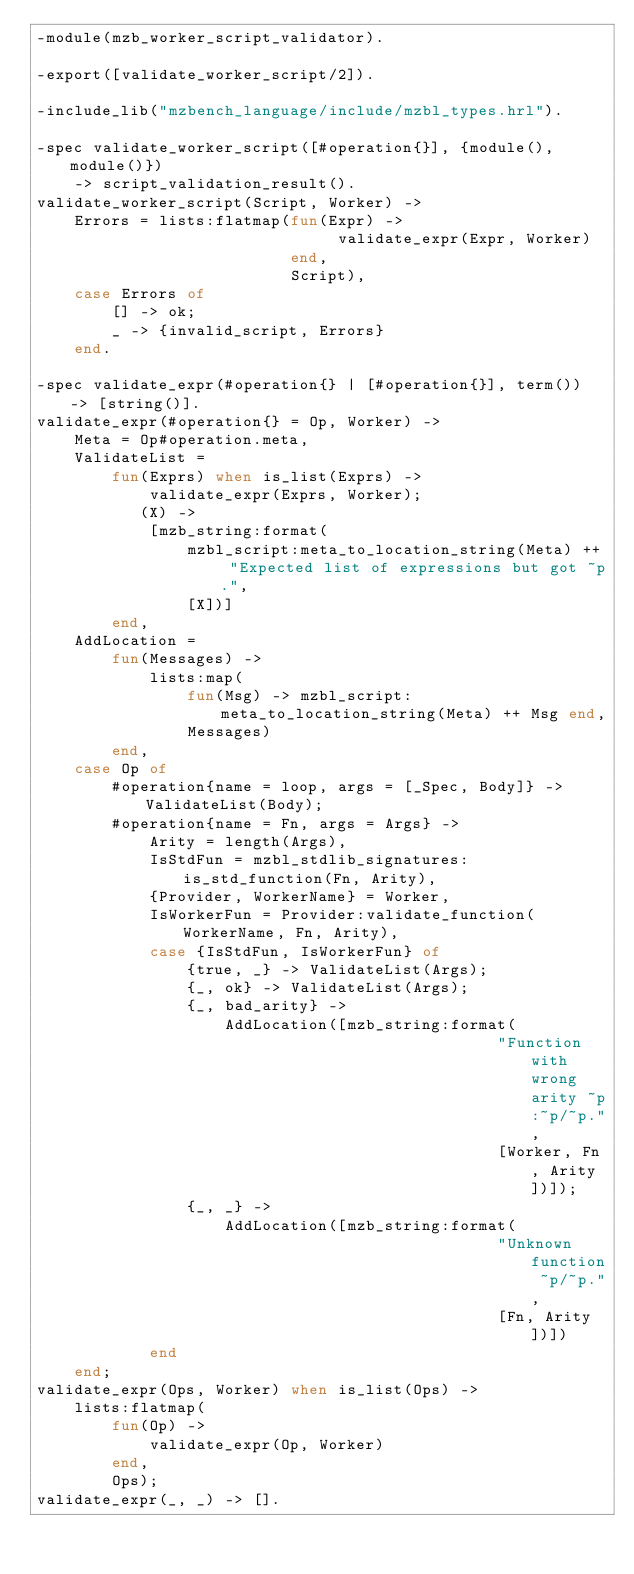<code> <loc_0><loc_0><loc_500><loc_500><_Erlang_>-module(mzb_worker_script_validator).

-export([validate_worker_script/2]).

-include_lib("mzbench_language/include/mzbl_types.hrl").

-spec validate_worker_script([#operation{}], {module(), module()})
    -> script_validation_result().
validate_worker_script(Script, Worker) ->
    Errors = lists:flatmap(fun(Expr) ->
                                validate_expr(Expr, Worker)
                           end,
                           Script),
    case Errors of
        [] -> ok;
        _ -> {invalid_script, Errors}
    end.

-spec validate_expr(#operation{} | [#operation{}], term()) -> [string()].
validate_expr(#operation{} = Op, Worker) ->
    Meta = Op#operation.meta,
    ValidateList =
        fun(Exprs) when is_list(Exprs) ->
            validate_expr(Exprs, Worker);
           (X) ->
            [mzb_string:format(
                mzbl_script:meta_to_location_string(Meta) ++ "Expected list of expressions but got ~p.",
                [X])]
        end,
    AddLocation =
        fun(Messages) ->
            lists:map(
                fun(Msg) -> mzbl_script:meta_to_location_string(Meta) ++ Msg end,
                Messages)
        end,
    case Op of
        #operation{name = loop, args = [_Spec, Body]} -> ValidateList(Body);
        #operation{name = Fn, args = Args} ->
            Arity = length(Args),
            IsStdFun = mzbl_stdlib_signatures:is_std_function(Fn, Arity),
            {Provider, WorkerName} = Worker,
            IsWorkerFun = Provider:validate_function(WorkerName, Fn, Arity),
            case {IsStdFun, IsWorkerFun} of
                {true, _} -> ValidateList(Args);
                {_, ok} -> ValidateList(Args);
                {_, bad_arity} ->
                    AddLocation([mzb_string:format(
                                                 "Function with wrong arity ~p:~p/~p.",
                                                 [Worker, Fn, Arity])]);
                {_, _} ->
                    AddLocation([mzb_string:format(
                                                 "Unknown function ~p/~p.",
                                                 [Fn, Arity])])
            end
    end;
validate_expr(Ops, Worker) when is_list(Ops) ->
    lists:flatmap(
        fun(Op) ->
            validate_expr(Op, Worker)
        end,
        Ops);
validate_expr(_, _) -> [].

</code> 